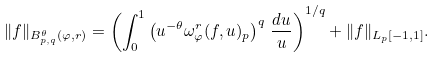Convert formula to latex. <formula><loc_0><loc_0><loc_500><loc_500>\| f \| _ { B ^ { \theta } _ { p , q } ( \varphi , r ) } = \left ( \int ^ { 1 } _ { 0 } \left ( u ^ { - \theta } \omega ^ { r } _ { \varphi } ( f , u ) _ { p } \right ) ^ { q } \, \frac { d u } { u } \right ) ^ { 1 / q } + \| f \| _ { L _ { p } [ - 1 , 1 ] } .</formula> 